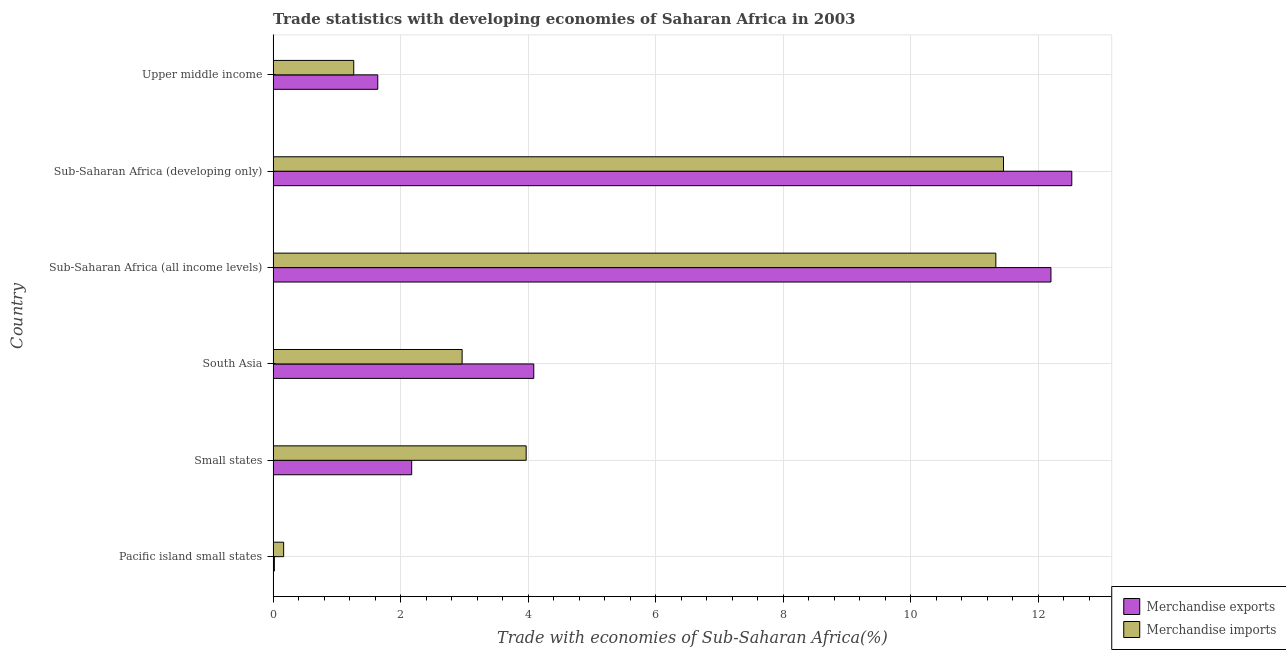How many different coloured bars are there?
Your response must be concise. 2. How many groups of bars are there?
Give a very brief answer. 6. Are the number of bars per tick equal to the number of legend labels?
Your response must be concise. Yes. How many bars are there on the 4th tick from the top?
Your answer should be compact. 2. How many bars are there on the 1st tick from the bottom?
Make the answer very short. 2. What is the label of the 2nd group of bars from the top?
Offer a very short reply. Sub-Saharan Africa (developing only). What is the merchandise imports in Upper middle income?
Offer a terse response. 1.26. Across all countries, what is the maximum merchandise exports?
Offer a very short reply. 12.52. Across all countries, what is the minimum merchandise exports?
Offer a very short reply. 0.02. In which country was the merchandise exports maximum?
Give a very brief answer. Sub-Saharan Africa (developing only). In which country was the merchandise exports minimum?
Your response must be concise. Pacific island small states. What is the total merchandise exports in the graph?
Offer a very short reply. 32.64. What is the difference between the merchandise imports in Pacific island small states and that in Sub-Saharan Africa (developing only)?
Your answer should be very brief. -11.29. What is the difference between the merchandise exports in Small states and the merchandise imports in Sub-Saharan Africa (developing only)?
Offer a terse response. -9.28. What is the average merchandise exports per country?
Make the answer very short. 5.44. What is the difference between the merchandise imports and merchandise exports in Pacific island small states?
Provide a succinct answer. 0.15. What is the ratio of the merchandise exports in Pacific island small states to that in Upper middle income?
Offer a terse response. 0.01. Is the merchandise imports in Pacific island small states less than that in South Asia?
Provide a succinct answer. Yes. What is the difference between the highest and the second highest merchandise imports?
Ensure brevity in your answer.  0.12. What is the difference between the highest and the lowest merchandise exports?
Your answer should be compact. 12.5. In how many countries, is the merchandise exports greater than the average merchandise exports taken over all countries?
Offer a very short reply. 2. Is the sum of the merchandise imports in South Asia and Sub-Saharan Africa (all income levels) greater than the maximum merchandise exports across all countries?
Ensure brevity in your answer.  Yes. What does the 2nd bar from the top in Sub-Saharan Africa (developing only) represents?
Give a very brief answer. Merchandise exports. What does the 2nd bar from the bottom in Upper middle income represents?
Ensure brevity in your answer.  Merchandise imports. How many bars are there?
Keep it short and to the point. 12. How many countries are there in the graph?
Offer a terse response. 6. Are the values on the major ticks of X-axis written in scientific E-notation?
Your response must be concise. No. Does the graph contain grids?
Your answer should be very brief. Yes. How many legend labels are there?
Offer a very short reply. 2. What is the title of the graph?
Provide a short and direct response. Trade statistics with developing economies of Saharan Africa in 2003. What is the label or title of the X-axis?
Your response must be concise. Trade with economies of Sub-Saharan Africa(%). What is the Trade with economies of Sub-Saharan Africa(%) in Merchandise exports in Pacific island small states?
Offer a very short reply. 0.02. What is the Trade with economies of Sub-Saharan Africa(%) in Merchandise imports in Pacific island small states?
Your answer should be very brief. 0.17. What is the Trade with economies of Sub-Saharan Africa(%) in Merchandise exports in Small states?
Give a very brief answer. 2.17. What is the Trade with economies of Sub-Saharan Africa(%) of Merchandise imports in Small states?
Give a very brief answer. 3.97. What is the Trade with economies of Sub-Saharan Africa(%) in Merchandise exports in South Asia?
Provide a succinct answer. 4.09. What is the Trade with economies of Sub-Saharan Africa(%) in Merchandise imports in South Asia?
Ensure brevity in your answer.  2.96. What is the Trade with economies of Sub-Saharan Africa(%) in Merchandise exports in Sub-Saharan Africa (all income levels)?
Offer a very short reply. 12.2. What is the Trade with economies of Sub-Saharan Africa(%) in Merchandise imports in Sub-Saharan Africa (all income levels)?
Offer a terse response. 11.33. What is the Trade with economies of Sub-Saharan Africa(%) in Merchandise exports in Sub-Saharan Africa (developing only)?
Provide a succinct answer. 12.52. What is the Trade with economies of Sub-Saharan Africa(%) in Merchandise imports in Sub-Saharan Africa (developing only)?
Ensure brevity in your answer.  11.45. What is the Trade with economies of Sub-Saharan Africa(%) of Merchandise exports in Upper middle income?
Give a very brief answer. 1.64. What is the Trade with economies of Sub-Saharan Africa(%) in Merchandise imports in Upper middle income?
Your answer should be compact. 1.26. Across all countries, what is the maximum Trade with economies of Sub-Saharan Africa(%) in Merchandise exports?
Offer a very short reply. 12.52. Across all countries, what is the maximum Trade with economies of Sub-Saharan Africa(%) in Merchandise imports?
Ensure brevity in your answer.  11.45. Across all countries, what is the minimum Trade with economies of Sub-Saharan Africa(%) in Merchandise exports?
Your response must be concise. 0.02. Across all countries, what is the minimum Trade with economies of Sub-Saharan Africa(%) in Merchandise imports?
Offer a very short reply. 0.17. What is the total Trade with economies of Sub-Saharan Africa(%) of Merchandise exports in the graph?
Ensure brevity in your answer.  32.64. What is the total Trade with economies of Sub-Saharan Africa(%) in Merchandise imports in the graph?
Ensure brevity in your answer.  31.14. What is the difference between the Trade with economies of Sub-Saharan Africa(%) in Merchandise exports in Pacific island small states and that in Small states?
Your answer should be compact. -2.15. What is the difference between the Trade with economies of Sub-Saharan Africa(%) of Merchandise imports in Pacific island small states and that in Small states?
Your answer should be compact. -3.8. What is the difference between the Trade with economies of Sub-Saharan Africa(%) in Merchandise exports in Pacific island small states and that in South Asia?
Provide a short and direct response. -4.07. What is the difference between the Trade with economies of Sub-Saharan Africa(%) in Merchandise imports in Pacific island small states and that in South Asia?
Your answer should be very brief. -2.8. What is the difference between the Trade with economies of Sub-Saharan Africa(%) of Merchandise exports in Pacific island small states and that in Sub-Saharan Africa (all income levels)?
Provide a short and direct response. -12.18. What is the difference between the Trade with economies of Sub-Saharan Africa(%) in Merchandise imports in Pacific island small states and that in Sub-Saharan Africa (all income levels)?
Provide a short and direct response. -11.17. What is the difference between the Trade with economies of Sub-Saharan Africa(%) in Merchandise exports in Pacific island small states and that in Sub-Saharan Africa (developing only)?
Keep it short and to the point. -12.5. What is the difference between the Trade with economies of Sub-Saharan Africa(%) of Merchandise imports in Pacific island small states and that in Sub-Saharan Africa (developing only)?
Provide a short and direct response. -11.29. What is the difference between the Trade with economies of Sub-Saharan Africa(%) in Merchandise exports in Pacific island small states and that in Upper middle income?
Offer a very short reply. -1.62. What is the difference between the Trade with economies of Sub-Saharan Africa(%) of Merchandise imports in Pacific island small states and that in Upper middle income?
Provide a short and direct response. -1.1. What is the difference between the Trade with economies of Sub-Saharan Africa(%) in Merchandise exports in Small states and that in South Asia?
Your response must be concise. -1.91. What is the difference between the Trade with economies of Sub-Saharan Africa(%) in Merchandise imports in Small states and that in South Asia?
Offer a terse response. 1. What is the difference between the Trade with economies of Sub-Saharan Africa(%) in Merchandise exports in Small states and that in Sub-Saharan Africa (all income levels)?
Offer a terse response. -10.02. What is the difference between the Trade with economies of Sub-Saharan Africa(%) of Merchandise imports in Small states and that in Sub-Saharan Africa (all income levels)?
Your answer should be compact. -7.36. What is the difference between the Trade with economies of Sub-Saharan Africa(%) of Merchandise exports in Small states and that in Sub-Saharan Africa (developing only)?
Provide a short and direct response. -10.35. What is the difference between the Trade with economies of Sub-Saharan Africa(%) in Merchandise imports in Small states and that in Sub-Saharan Africa (developing only)?
Ensure brevity in your answer.  -7.48. What is the difference between the Trade with economies of Sub-Saharan Africa(%) in Merchandise exports in Small states and that in Upper middle income?
Your response must be concise. 0.53. What is the difference between the Trade with economies of Sub-Saharan Africa(%) in Merchandise imports in Small states and that in Upper middle income?
Your answer should be compact. 2.7. What is the difference between the Trade with economies of Sub-Saharan Africa(%) of Merchandise exports in South Asia and that in Sub-Saharan Africa (all income levels)?
Give a very brief answer. -8.11. What is the difference between the Trade with economies of Sub-Saharan Africa(%) in Merchandise imports in South Asia and that in Sub-Saharan Africa (all income levels)?
Ensure brevity in your answer.  -8.37. What is the difference between the Trade with economies of Sub-Saharan Africa(%) of Merchandise exports in South Asia and that in Sub-Saharan Africa (developing only)?
Your answer should be very brief. -8.44. What is the difference between the Trade with economies of Sub-Saharan Africa(%) in Merchandise imports in South Asia and that in Sub-Saharan Africa (developing only)?
Provide a short and direct response. -8.49. What is the difference between the Trade with economies of Sub-Saharan Africa(%) of Merchandise exports in South Asia and that in Upper middle income?
Offer a terse response. 2.45. What is the difference between the Trade with economies of Sub-Saharan Africa(%) of Merchandise imports in South Asia and that in Upper middle income?
Make the answer very short. 1.7. What is the difference between the Trade with economies of Sub-Saharan Africa(%) of Merchandise exports in Sub-Saharan Africa (all income levels) and that in Sub-Saharan Africa (developing only)?
Ensure brevity in your answer.  -0.33. What is the difference between the Trade with economies of Sub-Saharan Africa(%) in Merchandise imports in Sub-Saharan Africa (all income levels) and that in Sub-Saharan Africa (developing only)?
Your answer should be compact. -0.12. What is the difference between the Trade with economies of Sub-Saharan Africa(%) in Merchandise exports in Sub-Saharan Africa (all income levels) and that in Upper middle income?
Provide a short and direct response. 10.56. What is the difference between the Trade with economies of Sub-Saharan Africa(%) of Merchandise imports in Sub-Saharan Africa (all income levels) and that in Upper middle income?
Provide a short and direct response. 10.07. What is the difference between the Trade with economies of Sub-Saharan Africa(%) in Merchandise exports in Sub-Saharan Africa (developing only) and that in Upper middle income?
Make the answer very short. 10.88. What is the difference between the Trade with economies of Sub-Saharan Africa(%) of Merchandise imports in Sub-Saharan Africa (developing only) and that in Upper middle income?
Provide a succinct answer. 10.19. What is the difference between the Trade with economies of Sub-Saharan Africa(%) of Merchandise exports in Pacific island small states and the Trade with economies of Sub-Saharan Africa(%) of Merchandise imports in Small states?
Give a very brief answer. -3.95. What is the difference between the Trade with economies of Sub-Saharan Africa(%) in Merchandise exports in Pacific island small states and the Trade with economies of Sub-Saharan Africa(%) in Merchandise imports in South Asia?
Make the answer very short. -2.94. What is the difference between the Trade with economies of Sub-Saharan Africa(%) in Merchandise exports in Pacific island small states and the Trade with economies of Sub-Saharan Africa(%) in Merchandise imports in Sub-Saharan Africa (all income levels)?
Offer a terse response. -11.31. What is the difference between the Trade with economies of Sub-Saharan Africa(%) in Merchandise exports in Pacific island small states and the Trade with economies of Sub-Saharan Africa(%) in Merchandise imports in Sub-Saharan Africa (developing only)?
Make the answer very short. -11.43. What is the difference between the Trade with economies of Sub-Saharan Africa(%) in Merchandise exports in Pacific island small states and the Trade with economies of Sub-Saharan Africa(%) in Merchandise imports in Upper middle income?
Provide a succinct answer. -1.24. What is the difference between the Trade with economies of Sub-Saharan Africa(%) of Merchandise exports in Small states and the Trade with economies of Sub-Saharan Africa(%) of Merchandise imports in South Asia?
Provide a short and direct response. -0.79. What is the difference between the Trade with economies of Sub-Saharan Africa(%) of Merchandise exports in Small states and the Trade with economies of Sub-Saharan Africa(%) of Merchandise imports in Sub-Saharan Africa (all income levels)?
Your response must be concise. -9.16. What is the difference between the Trade with economies of Sub-Saharan Africa(%) in Merchandise exports in Small states and the Trade with economies of Sub-Saharan Africa(%) in Merchandise imports in Sub-Saharan Africa (developing only)?
Offer a very short reply. -9.28. What is the difference between the Trade with economies of Sub-Saharan Africa(%) in Merchandise exports in Small states and the Trade with economies of Sub-Saharan Africa(%) in Merchandise imports in Upper middle income?
Provide a succinct answer. 0.91. What is the difference between the Trade with economies of Sub-Saharan Africa(%) of Merchandise exports in South Asia and the Trade with economies of Sub-Saharan Africa(%) of Merchandise imports in Sub-Saharan Africa (all income levels)?
Offer a terse response. -7.25. What is the difference between the Trade with economies of Sub-Saharan Africa(%) of Merchandise exports in South Asia and the Trade with economies of Sub-Saharan Africa(%) of Merchandise imports in Sub-Saharan Africa (developing only)?
Provide a succinct answer. -7.37. What is the difference between the Trade with economies of Sub-Saharan Africa(%) in Merchandise exports in South Asia and the Trade with economies of Sub-Saharan Africa(%) in Merchandise imports in Upper middle income?
Give a very brief answer. 2.82. What is the difference between the Trade with economies of Sub-Saharan Africa(%) in Merchandise exports in Sub-Saharan Africa (all income levels) and the Trade with economies of Sub-Saharan Africa(%) in Merchandise imports in Sub-Saharan Africa (developing only)?
Your answer should be compact. 0.74. What is the difference between the Trade with economies of Sub-Saharan Africa(%) of Merchandise exports in Sub-Saharan Africa (all income levels) and the Trade with economies of Sub-Saharan Africa(%) of Merchandise imports in Upper middle income?
Keep it short and to the point. 10.93. What is the difference between the Trade with economies of Sub-Saharan Africa(%) of Merchandise exports in Sub-Saharan Africa (developing only) and the Trade with economies of Sub-Saharan Africa(%) of Merchandise imports in Upper middle income?
Ensure brevity in your answer.  11.26. What is the average Trade with economies of Sub-Saharan Africa(%) of Merchandise exports per country?
Offer a terse response. 5.44. What is the average Trade with economies of Sub-Saharan Africa(%) in Merchandise imports per country?
Ensure brevity in your answer.  5.19. What is the difference between the Trade with economies of Sub-Saharan Africa(%) in Merchandise exports and Trade with economies of Sub-Saharan Africa(%) in Merchandise imports in Pacific island small states?
Your answer should be very brief. -0.15. What is the difference between the Trade with economies of Sub-Saharan Africa(%) in Merchandise exports and Trade with economies of Sub-Saharan Africa(%) in Merchandise imports in Small states?
Provide a succinct answer. -1.79. What is the difference between the Trade with economies of Sub-Saharan Africa(%) in Merchandise exports and Trade with economies of Sub-Saharan Africa(%) in Merchandise imports in South Asia?
Provide a short and direct response. 1.12. What is the difference between the Trade with economies of Sub-Saharan Africa(%) of Merchandise exports and Trade with economies of Sub-Saharan Africa(%) of Merchandise imports in Sub-Saharan Africa (all income levels)?
Offer a very short reply. 0.86. What is the difference between the Trade with economies of Sub-Saharan Africa(%) in Merchandise exports and Trade with economies of Sub-Saharan Africa(%) in Merchandise imports in Sub-Saharan Africa (developing only)?
Offer a terse response. 1.07. What is the difference between the Trade with economies of Sub-Saharan Africa(%) of Merchandise exports and Trade with economies of Sub-Saharan Africa(%) of Merchandise imports in Upper middle income?
Your response must be concise. 0.38. What is the ratio of the Trade with economies of Sub-Saharan Africa(%) in Merchandise exports in Pacific island small states to that in Small states?
Keep it short and to the point. 0.01. What is the ratio of the Trade with economies of Sub-Saharan Africa(%) of Merchandise imports in Pacific island small states to that in Small states?
Give a very brief answer. 0.04. What is the ratio of the Trade with economies of Sub-Saharan Africa(%) in Merchandise exports in Pacific island small states to that in South Asia?
Offer a very short reply. 0. What is the ratio of the Trade with economies of Sub-Saharan Africa(%) in Merchandise imports in Pacific island small states to that in South Asia?
Make the answer very short. 0.06. What is the ratio of the Trade with economies of Sub-Saharan Africa(%) of Merchandise exports in Pacific island small states to that in Sub-Saharan Africa (all income levels)?
Provide a succinct answer. 0. What is the ratio of the Trade with economies of Sub-Saharan Africa(%) in Merchandise imports in Pacific island small states to that in Sub-Saharan Africa (all income levels)?
Keep it short and to the point. 0.01. What is the ratio of the Trade with economies of Sub-Saharan Africa(%) of Merchandise exports in Pacific island small states to that in Sub-Saharan Africa (developing only)?
Your response must be concise. 0. What is the ratio of the Trade with economies of Sub-Saharan Africa(%) of Merchandise imports in Pacific island small states to that in Sub-Saharan Africa (developing only)?
Provide a short and direct response. 0.01. What is the ratio of the Trade with economies of Sub-Saharan Africa(%) in Merchandise exports in Pacific island small states to that in Upper middle income?
Your response must be concise. 0.01. What is the ratio of the Trade with economies of Sub-Saharan Africa(%) of Merchandise imports in Pacific island small states to that in Upper middle income?
Ensure brevity in your answer.  0.13. What is the ratio of the Trade with economies of Sub-Saharan Africa(%) of Merchandise exports in Small states to that in South Asia?
Give a very brief answer. 0.53. What is the ratio of the Trade with economies of Sub-Saharan Africa(%) of Merchandise imports in Small states to that in South Asia?
Ensure brevity in your answer.  1.34. What is the ratio of the Trade with economies of Sub-Saharan Africa(%) of Merchandise exports in Small states to that in Sub-Saharan Africa (all income levels)?
Provide a short and direct response. 0.18. What is the ratio of the Trade with economies of Sub-Saharan Africa(%) of Merchandise imports in Small states to that in Sub-Saharan Africa (all income levels)?
Your response must be concise. 0.35. What is the ratio of the Trade with economies of Sub-Saharan Africa(%) of Merchandise exports in Small states to that in Sub-Saharan Africa (developing only)?
Offer a terse response. 0.17. What is the ratio of the Trade with economies of Sub-Saharan Africa(%) of Merchandise imports in Small states to that in Sub-Saharan Africa (developing only)?
Provide a succinct answer. 0.35. What is the ratio of the Trade with economies of Sub-Saharan Africa(%) in Merchandise exports in Small states to that in Upper middle income?
Offer a very short reply. 1.32. What is the ratio of the Trade with economies of Sub-Saharan Africa(%) of Merchandise imports in Small states to that in Upper middle income?
Give a very brief answer. 3.14. What is the ratio of the Trade with economies of Sub-Saharan Africa(%) in Merchandise exports in South Asia to that in Sub-Saharan Africa (all income levels)?
Offer a very short reply. 0.34. What is the ratio of the Trade with economies of Sub-Saharan Africa(%) of Merchandise imports in South Asia to that in Sub-Saharan Africa (all income levels)?
Your answer should be very brief. 0.26. What is the ratio of the Trade with economies of Sub-Saharan Africa(%) in Merchandise exports in South Asia to that in Sub-Saharan Africa (developing only)?
Ensure brevity in your answer.  0.33. What is the ratio of the Trade with economies of Sub-Saharan Africa(%) of Merchandise imports in South Asia to that in Sub-Saharan Africa (developing only)?
Give a very brief answer. 0.26. What is the ratio of the Trade with economies of Sub-Saharan Africa(%) of Merchandise exports in South Asia to that in Upper middle income?
Provide a short and direct response. 2.49. What is the ratio of the Trade with economies of Sub-Saharan Africa(%) of Merchandise imports in South Asia to that in Upper middle income?
Provide a short and direct response. 2.34. What is the ratio of the Trade with economies of Sub-Saharan Africa(%) in Merchandise exports in Sub-Saharan Africa (all income levels) to that in Sub-Saharan Africa (developing only)?
Provide a short and direct response. 0.97. What is the ratio of the Trade with economies of Sub-Saharan Africa(%) of Merchandise imports in Sub-Saharan Africa (all income levels) to that in Sub-Saharan Africa (developing only)?
Provide a short and direct response. 0.99. What is the ratio of the Trade with economies of Sub-Saharan Africa(%) in Merchandise exports in Sub-Saharan Africa (all income levels) to that in Upper middle income?
Offer a very short reply. 7.43. What is the ratio of the Trade with economies of Sub-Saharan Africa(%) of Merchandise imports in Sub-Saharan Africa (all income levels) to that in Upper middle income?
Your answer should be very brief. 8.96. What is the ratio of the Trade with economies of Sub-Saharan Africa(%) in Merchandise exports in Sub-Saharan Africa (developing only) to that in Upper middle income?
Offer a terse response. 7.63. What is the ratio of the Trade with economies of Sub-Saharan Africa(%) in Merchandise imports in Sub-Saharan Africa (developing only) to that in Upper middle income?
Make the answer very short. 9.06. What is the difference between the highest and the second highest Trade with economies of Sub-Saharan Africa(%) in Merchandise exports?
Ensure brevity in your answer.  0.33. What is the difference between the highest and the second highest Trade with economies of Sub-Saharan Africa(%) in Merchandise imports?
Provide a short and direct response. 0.12. What is the difference between the highest and the lowest Trade with economies of Sub-Saharan Africa(%) of Merchandise exports?
Make the answer very short. 12.5. What is the difference between the highest and the lowest Trade with economies of Sub-Saharan Africa(%) of Merchandise imports?
Offer a very short reply. 11.29. 